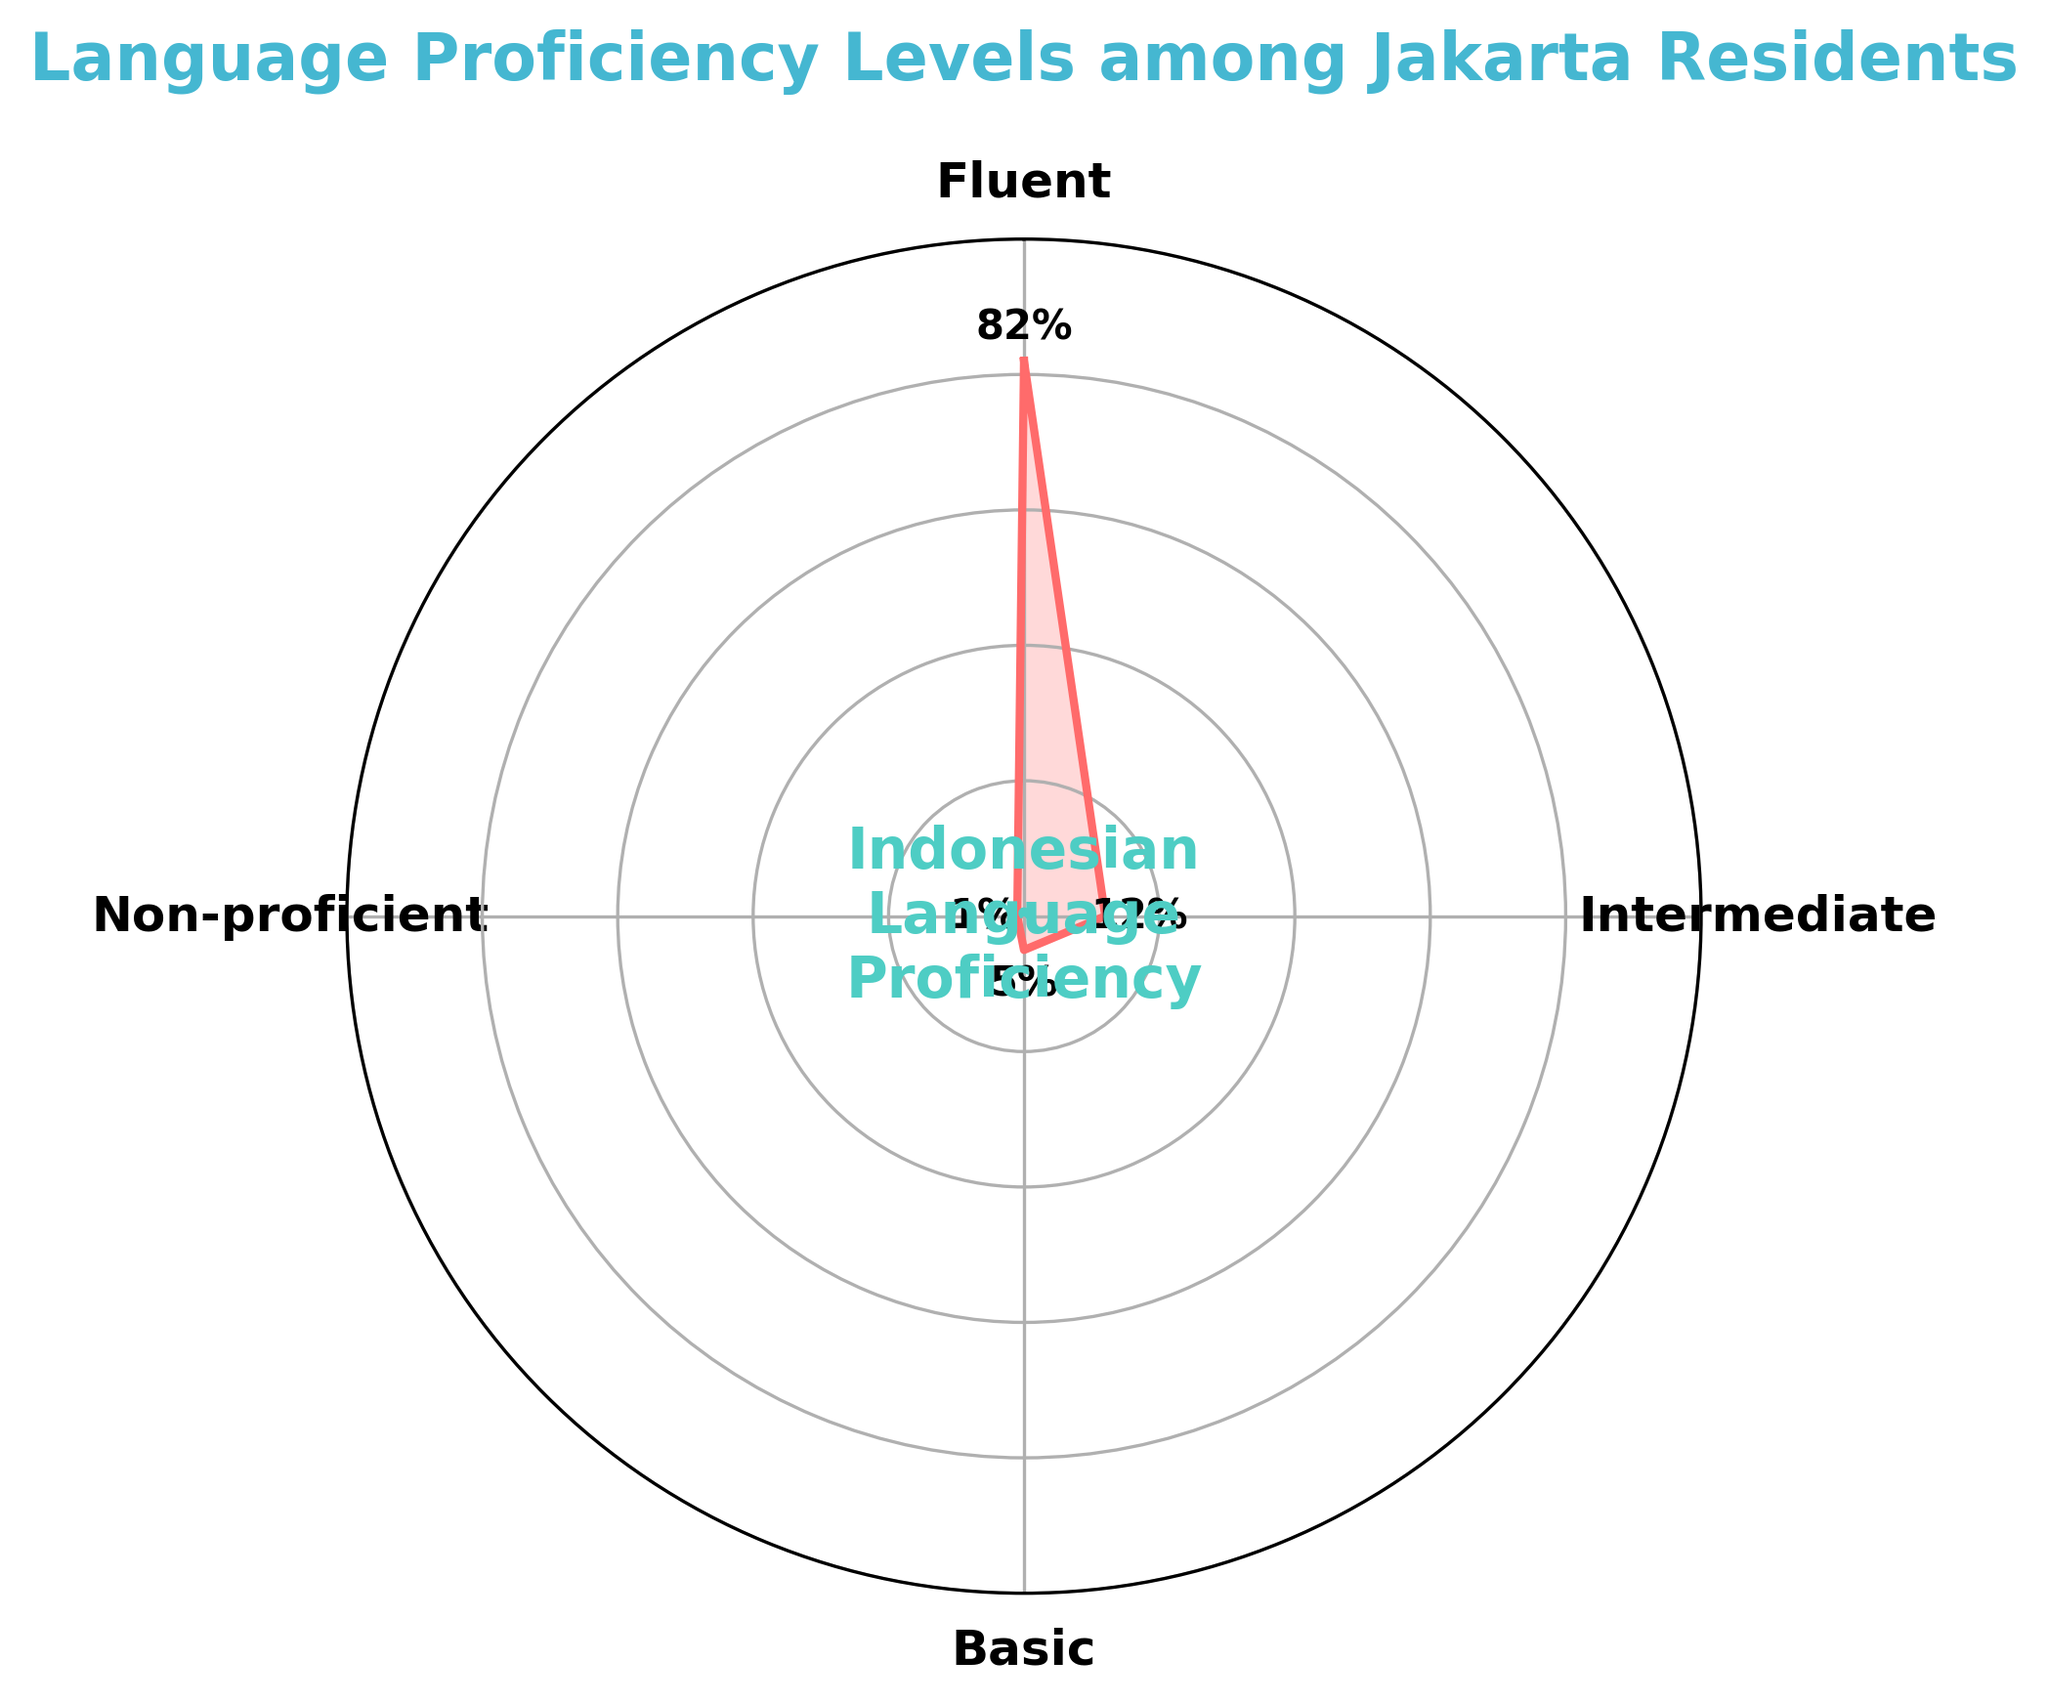What's the highest proficiency level among Jakarta residents? The highest proficiency level can be identified by the largest percentage. Based on the plot, 'Fluent' has the highest percentage.
Answer: Fluent What percentage of Jakarta residents are at the Intermediate level of Indonesian proficiency? Look at the polar chart for the segment labeled 'Intermediate' and note the percentage value.
Answer: 12% What is the sum of the percentages for Basic and Non-proficient proficiency levels? Identify the percentages for 'Basic' (5%) and 'Non-proficient' (1%) and add them together. 5 + 1 = 6
Answer: 6% How does the proportion of Fluent speakers compare to Intermediate speakers? The percentage labeled 'Fluent' (82%) is significantly higher than the percentage labeled 'Intermediate' (12%).
Answer: Fluent speakers have a much higher proportion Which proficiency levels together make up less than 20% of Jakarta residents? Add up the percentages of 'Intermediate' (12%), 'Basic' (5%), and 'Non-proficient' (1%). 12 + 5 + 1 = 18, which is less than 20.
Answer: Intermediate, Basic, and Non-proficient What's the difference in percentage between Fluent and Basic proficiency levels? Subtract the percentage labeled 'Basic' from the percentage labeled 'Fluent'. 82 - 5 = 77
Answer: 77% If a random person from Jakarta is chosen, what is the probability that they are not Fluent in Indonesian? Add up the percentages for Intermediate, Basic, and Non-proficient levels. 12 + 5 + 1 = 18
Answer: 18% What message does the center of the chart display? The text in the center circle of the polar chart displays "Indonesian Language Proficiency".
Answer: Indonesian Language Proficiency What's the average percentage of residents in the Non-fluent categories (Intermediate, Basic, and Non-proficient)? Sum up the percentages of 'Intermediate' (12%), 'Basic' (5%), and 'Non-proficient' (1%) and divide by 3 to find the average. (12 + 5 + 1) / 3 = 6
Answer: 6% What is the second most common proficiency level among Jakarta residents? Identify the category with the second highest percentage after 'Fluent'. 'Intermediate' has the next highest percentage at 12%.
Answer: Intermediate 